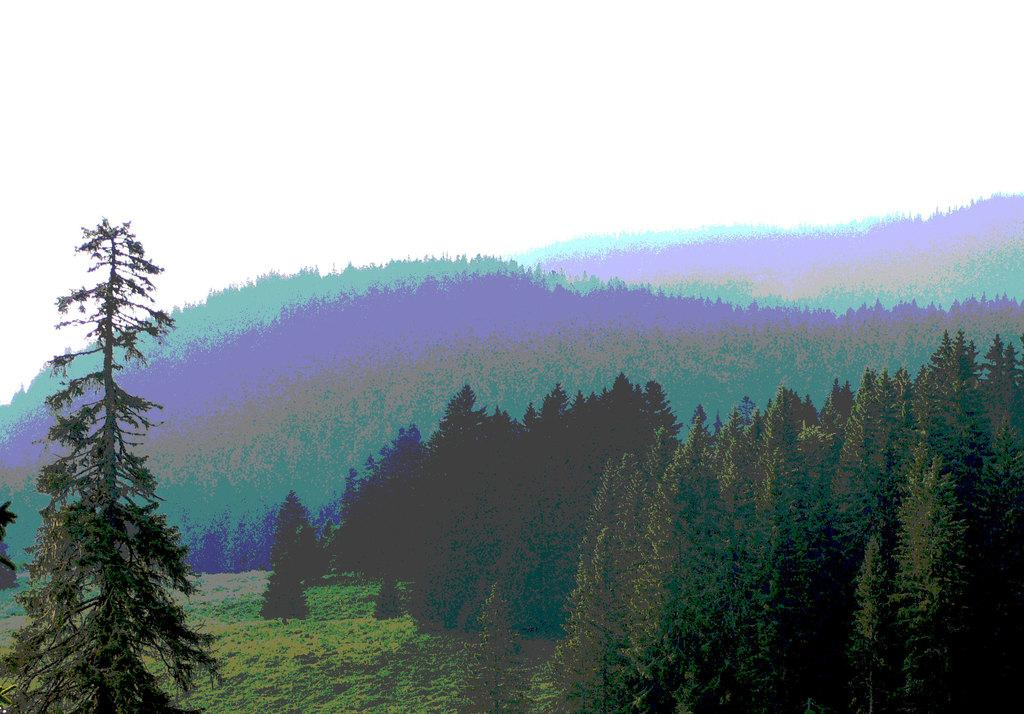What type of vegetation can be seen in the image? There are trees in the image. What type of metal is being cast in the image? There is no metal or casting process present in the image; it only features trees. 